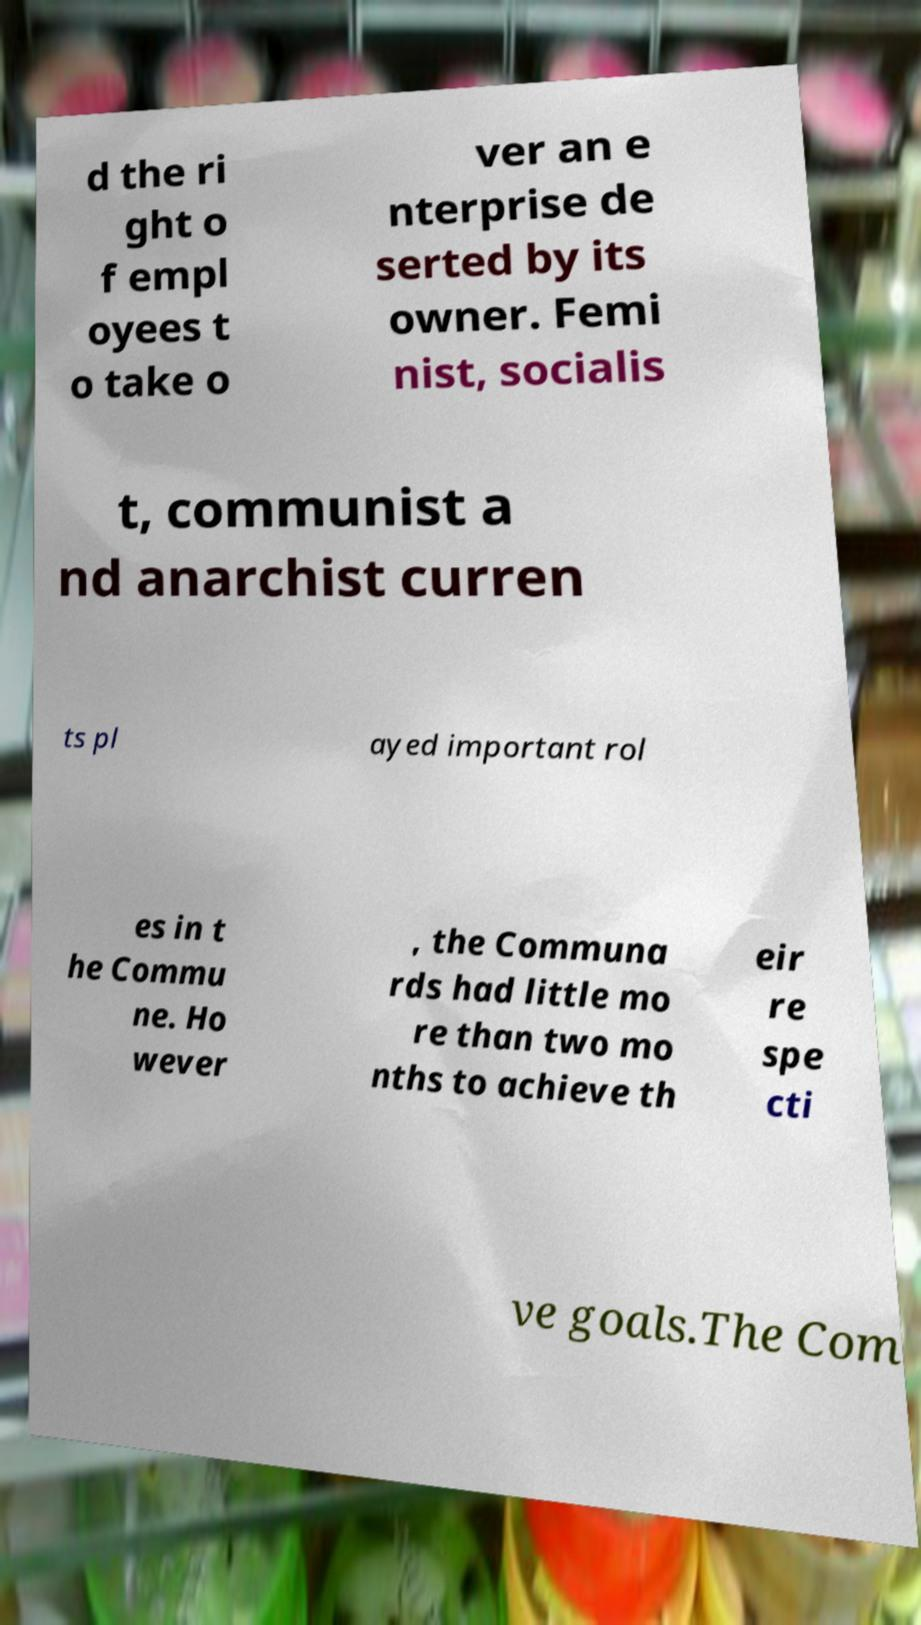For documentation purposes, I need the text within this image transcribed. Could you provide that? d the ri ght o f empl oyees t o take o ver an e nterprise de serted by its owner. Femi nist, socialis t, communist a nd anarchist curren ts pl ayed important rol es in t he Commu ne. Ho wever , the Communa rds had little mo re than two mo nths to achieve th eir re spe cti ve goals.The Com 